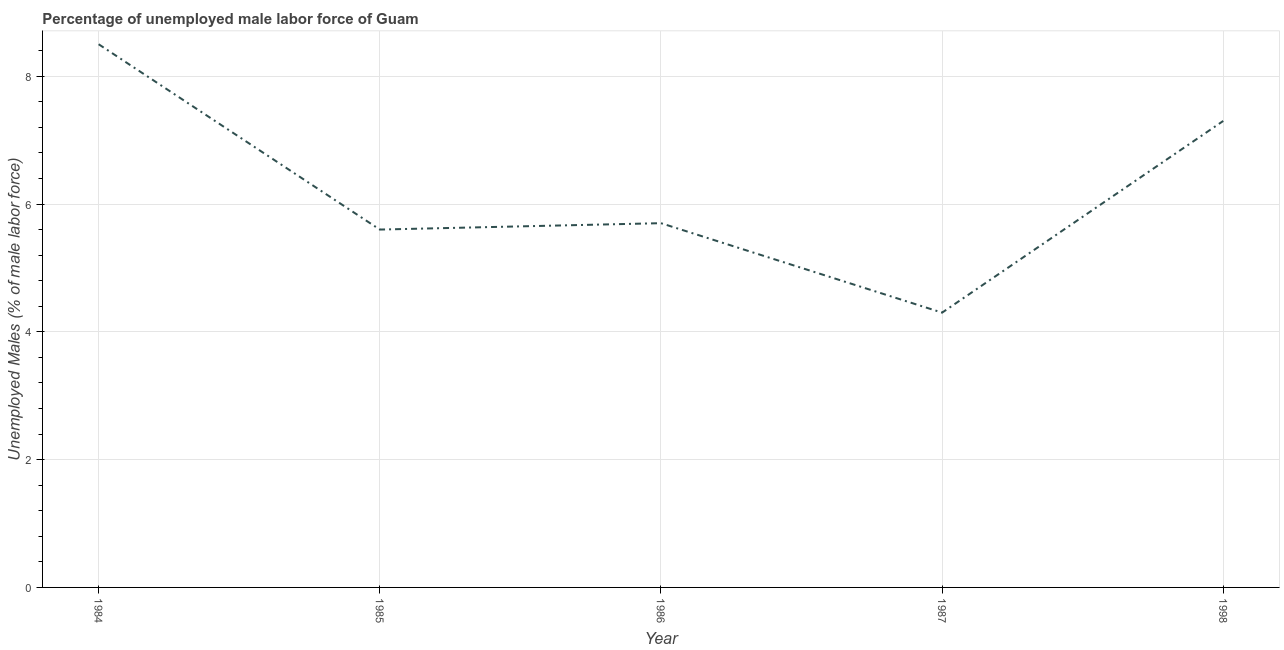What is the total unemployed male labour force in 1986?
Provide a succinct answer. 5.7. Across all years, what is the maximum total unemployed male labour force?
Ensure brevity in your answer.  8.5. Across all years, what is the minimum total unemployed male labour force?
Your answer should be compact. 4.3. In which year was the total unemployed male labour force maximum?
Offer a very short reply. 1984. What is the sum of the total unemployed male labour force?
Offer a very short reply. 31.4. What is the difference between the total unemployed male labour force in 1984 and 1985?
Offer a terse response. 2.9. What is the average total unemployed male labour force per year?
Your answer should be very brief. 6.28. What is the median total unemployed male labour force?
Your response must be concise. 5.7. What is the ratio of the total unemployed male labour force in 1984 to that in 1986?
Your response must be concise. 1.49. Is the total unemployed male labour force in 1985 less than that in 1986?
Your answer should be compact. Yes. Is the difference between the total unemployed male labour force in 1984 and 1985 greater than the difference between any two years?
Provide a short and direct response. No. What is the difference between the highest and the second highest total unemployed male labour force?
Your response must be concise. 1.2. What is the difference between the highest and the lowest total unemployed male labour force?
Make the answer very short. 4.2. In how many years, is the total unemployed male labour force greater than the average total unemployed male labour force taken over all years?
Your answer should be compact. 2. How many lines are there?
Make the answer very short. 1. How many years are there in the graph?
Give a very brief answer. 5. Are the values on the major ticks of Y-axis written in scientific E-notation?
Provide a short and direct response. No. Does the graph contain grids?
Offer a very short reply. Yes. What is the title of the graph?
Your response must be concise. Percentage of unemployed male labor force of Guam. What is the label or title of the Y-axis?
Your response must be concise. Unemployed Males (% of male labor force). What is the Unemployed Males (% of male labor force) in 1984?
Make the answer very short. 8.5. What is the Unemployed Males (% of male labor force) in 1985?
Provide a succinct answer. 5.6. What is the Unemployed Males (% of male labor force) in 1986?
Your answer should be compact. 5.7. What is the Unemployed Males (% of male labor force) of 1987?
Give a very brief answer. 4.3. What is the Unemployed Males (% of male labor force) in 1998?
Give a very brief answer. 7.3. What is the difference between the Unemployed Males (% of male labor force) in 1984 and 1985?
Your answer should be very brief. 2.9. What is the difference between the Unemployed Males (% of male labor force) in 1985 and 1986?
Offer a very short reply. -0.1. What is the difference between the Unemployed Males (% of male labor force) in 1985 and 1998?
Ensure brevity in your answer.  -1.7. What is the difference between the Unemployed Males (% of male labor force) in 1986 and 1987?
Offer a very short reply. 1.4. What is the difference between the Unemployed Males (% of male labor force) in 1987 and 1998?
Your response must be concise. -3. What is the ratio of the Unemployed Males (% of male labor force) in 1984 to that in 1985?
Provide a succinct answer. 1.52. What is the ratio of the Unemployed Males (% of male labor force) in 1984 to that in 1986?
Provide a succinct answer. 1.49. What is the ratio of the Unemployed Males (% of male labor force) in 1984 to that in 1987?
Ensure brevity in your answer.  1.98. What is the ratio of the Unemployed Males (% of male labor force) in 1984 to that in 1998?
Give a very brief answer. 1.16. What is the ratio of the Unemployed Males (% of male labor force) in 1985 to that in 1987?
Your answer should be compact. 1.3. What is the ratio of the Unemployed Males (% of male labor force) in 1985 to that in 1998?
Keep it short and to the point. 0.77. What is the ratio of the Unemployed Males (% of male labor force) in 1986 to that in 1987?
Your answer should be compact. 1.33. What is the ratio of the Unemployed Males (% of male labor force) in 1986 to that in 1998?
Provide a succinct answer. 0.78. What is the ratio of the Unemployed Males (% of male labor force) in 1987 to that in 1998?
Provide a succinct answer. 0.59. 